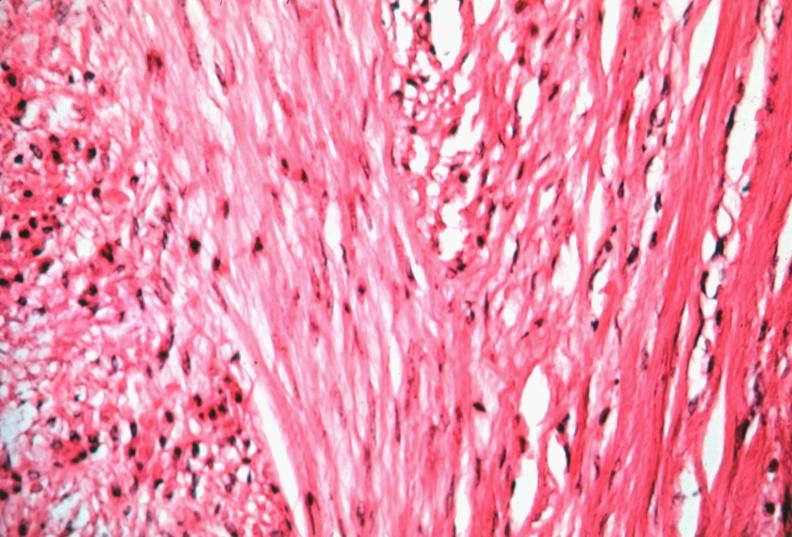s female reproductive present?
Answer the question using a single word or phrase. Yes 